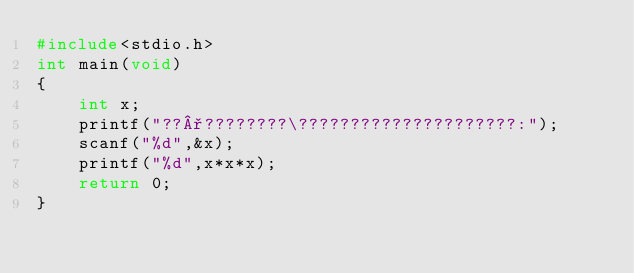<code> <loc_0><loc_0><loc_500><loc_500><_C_>#include<stdio.h>
int main(void)
{
	int x;
	printf("??°????????\?????????????????????:");
	scanf("%d",&x);
	printf("%d",x*x*x);
	return 0;
}</code> 